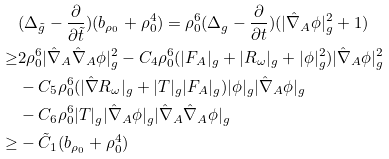Convert formula to latex. <formula><loc_0><loc_0><loc_500><loc_500>& ( \Delta _ { \tilde { g } } - \frac { \partial } { \partial \tilde { t } } ) ( b _ { \rho _ { 0 } } + \rho _ { 0 } ^ { 4 } ) = \rho _ { 0 } ^ { 6 } ( \Delta _ { g } - \frac { \partial } { \partial t } ) ( | \hat { \nabla } _ { A } \phi | _ { g } ^ { 2 } + 1 ) \\ \geq & 2 \rho _ { 0 } ^ { 6 } | \hat { \nabla } _ { A } \hat { \nabla } _ { A } \phi | _ { g } ^ { 2 } - C _ { 4 } \rho _ { 0 } ^ { 6 } ( | F _ { A } | _ { g } + | R _ { \omega } | _ { g } + | \phi | _ { g } ^ { 2 } ) | \hat { \nabla } _ { A } \phi | _ { g } ^ { 2 } \\ & - C _ { 5 } \rho _ { 0 } ^ { 6 } ( | \hat { \nabla } R _ { \omega } | _ { g } + | T | _ { g } | F _ { A } | _ { g } ) | \phi | _ { g } | \hat { \nabla } _ { A } \phi | _ { g } \\ & - C _ { 6 } \rho _ { 0 } ^ { 6 } | T | _ { g } | \hat { \nabla } _ { A } \phi | _ { g } | \hat { \nabla } _ { A } \hat { \nabla } _ { A } \phi | _ { g } \\ \geq & - \tilde { C } _ { 1 } ( b _ { \rho _ { 0 } } + \rho _ { 0 } ^ { 4 } )</formula> 